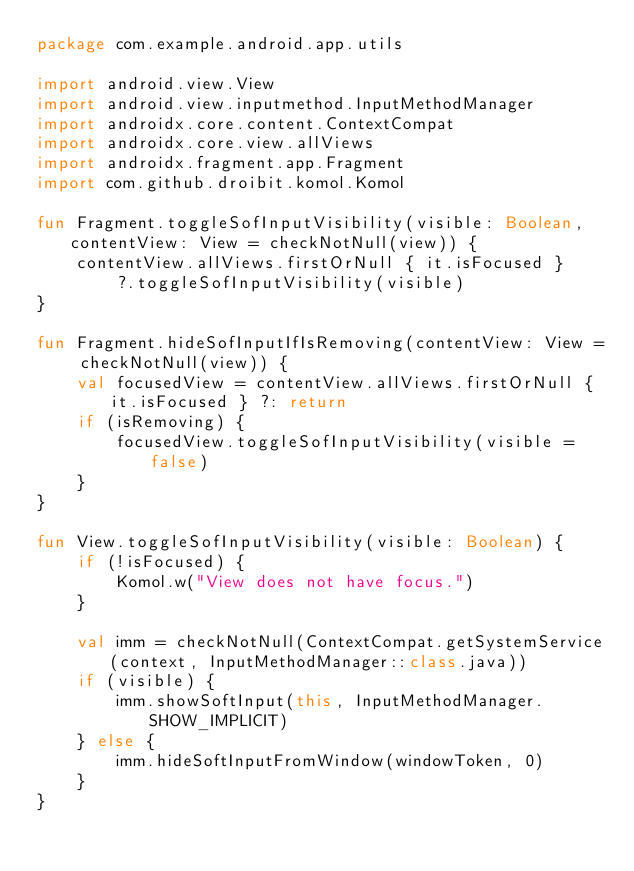<code> <loc_0><loc_0><loc_500><loc_500><_Kotlin_>package com.example.android.app.utils

import android.view.View
import android.view.inputmethod.InputMethodManager
import androidx.core.content.ContextCompat
import androidx.core.view.allViews
import androidx.fragment.app.Fragment
import com.github.droibit.komol.Komol

fun Fragment.toggleSofInputVisibility(visible: Boolean, contentView: View = checkNotNull(view)) {
    contentView.allViews.firstOrNull { it.isFocused }
        ?.toggleSofInputVisibility(visible)
}

fun Fragment.hideSofInputIfIsRemoving(contentView: View = checkNotNull(view)) {
    val focusedView = contentView.allViews.firstOrNull { it.isFocused } ?: return
    if (isRemoving) {
        focusedView.toggleSofInputVisibility(visible = false)
    }
}

fun View.toggleSofInputVisibility(visible: Boolean) {
    if (!isFocused) {
        Komol.w("View does not have focus.")
    }

    val imm = checkNotNull(ContextCompat.getSystemService(context, InputMethodManager::class.java))
    if (visible) {
        imm.showSoftInput(this, InputMethodManager.SHOW_IMPLICIT)
    } else {
        imm.hideSoftInputFromWindow(windowToken, 0)
    }
}</code> 